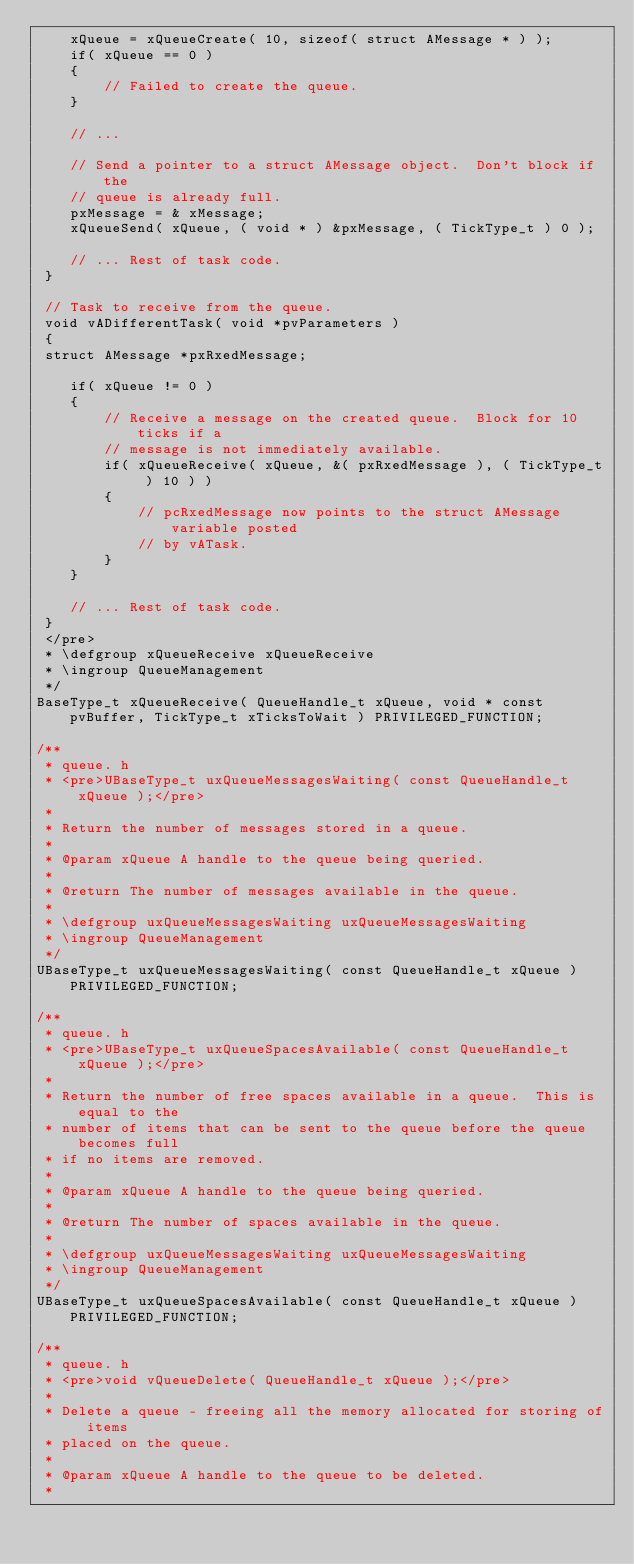Convert code to text. <code><loc_0><loc_0><loc_500><loc_500><_C_>    xQueue = xQueueCreate( 10, sizeof( struct AMessage * ) );
    if( xQueue == 0 )
    {
        // Failed to create the queue.
    }

    // ...

    // Send a pointer to a struct AMessage object.  Don't block if the
    // queue is already full.
    pxMessage = & xMessage;
    xQueueSend( xQueue, ( void * ) &pxMessage, ( TickType_t ) 0 );

    // ... Rest of task code.
 }

 // Task to receive from the queue.
 void vADifferentTask( void *pvParameters )
 {
 struct AMessage *pxRxedMessage;

    if( xQueue != 0 )
    {
        // Receive a message on the created queue.  Block for 10 ticks if a
        // message is not immediately available.
        if( xQueueReceive( xQueue, &( pxRxedMessage ), ( TickType_t ) 10 ) )
        {
            // pcRxedMessage now points to the struct AMessage variable posted
            // by vATask.
        }
    }

    // ... Rest of task code.
 }
 </pre>
 * \defgroup xQueueReceive xQueueReceive
 * \ingroup QueueManagement
 */
BaseType_t xQueueReceive( QueueHandle_t xQueue, void * const pvBuffer, TickType_t xTicksToWait ) PRIVILEGED_FUNCTION;

/**
 * queue. h
 * <pre>UBaseType_t uxQueueMessagesWaiting( const QueueHandle_t xQueue );</pre>
 *
 * Return the number of messages stored in a queue.
 *
 * @param xQueue A handle to the queue being queried.
 *
 * @return The number of messages available in the queue.
 *
 * \defgroup uxQueueMessagesWaiting uxQueueMessagesWaiting
 * \ingroup QueueManagement
 */
UBaseType_t uxQueueMessagesWaiting( const QueueHandle_t xQueue ) PRIVILEGED_FUNCTION;

/**
 * queue. h
 * <pre>UBaseType_t uxQueueSpacesAvailable( const QueueHandle_t xQueue );</pre>
 *
 * Return the number of free spaces available in a queue.  This is equal to the
 * number of items that can be sent to the queue before the queue becomes full
 * if no items are removed.
 *
 * @param xQueue A handle to the queue being queried.
 *
 * @return The number of spaces available in the queue.
 *
 * \defgroup uxQueueMessagesWaiting uxQueueMessagesWaiting
 * \ingroup QueueManagement
 */
UBaseType_t uxQueueSpacesAvailable( const QueueHandle_t xQueue ) PRIVILEGED_FUNCTION;

/**
 * queue. h
 * <pre>void vQueueDelete( QueueHandle_t xQueue );</pre>
 *
 * Delete a queue - freeing all the memory allocated for storing of items
 * placed on the queue.
 *
 * @param xQueue A handle to the queue to be deleted.
 *</code> 